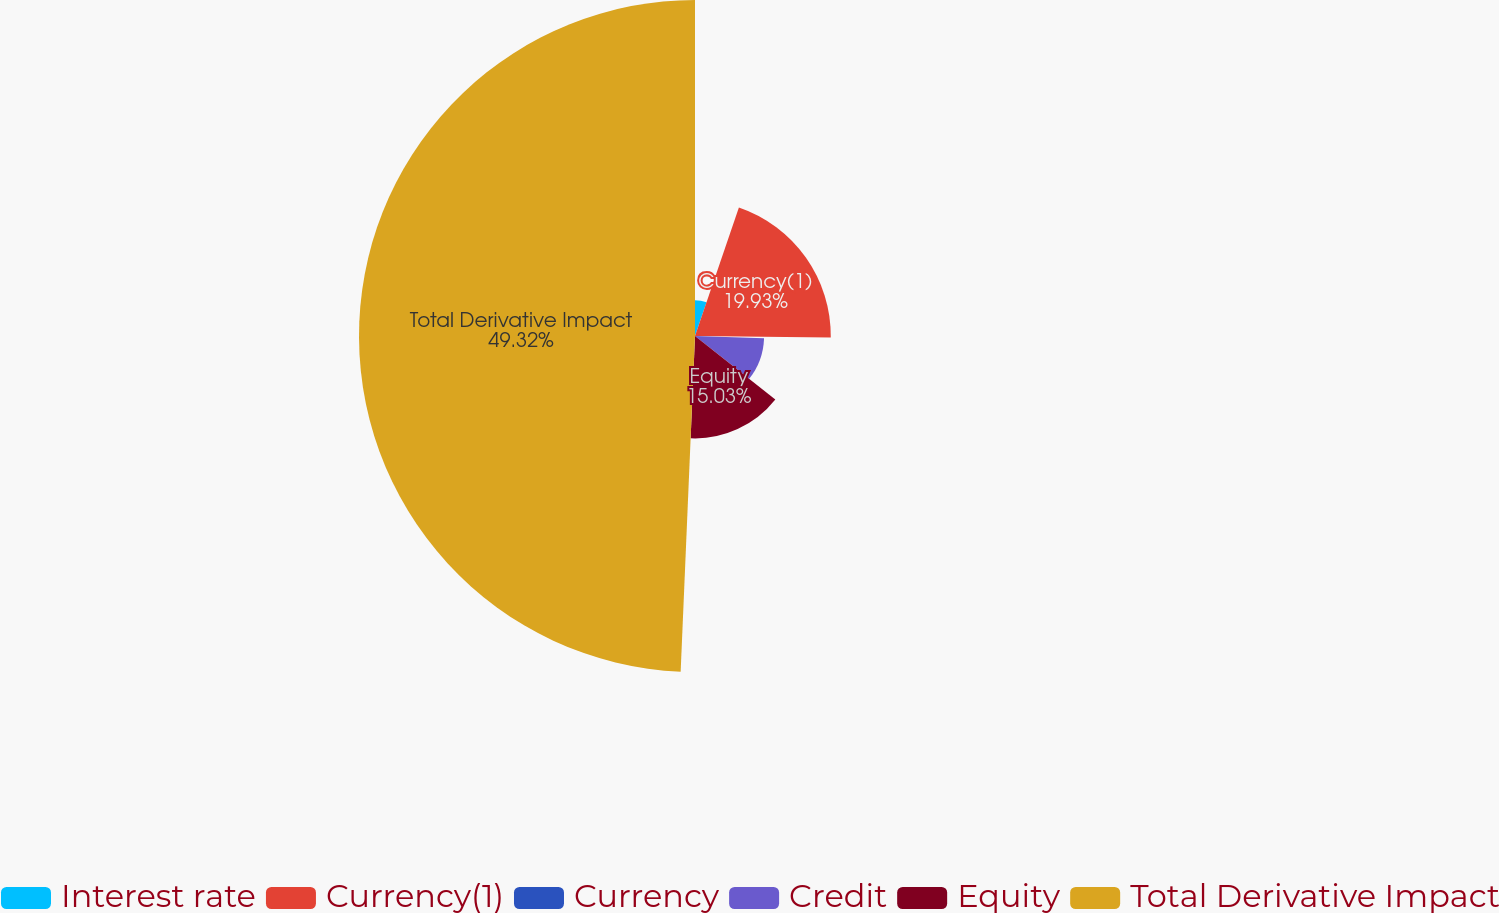<chart> <loc_0><loc_0><loc_500><loc_500><pie_chart><fcel>Interest rate<fcel>Currency(1)<fcel>Currency<fcel>Credit<fcel>Equity<fcel>Total Derivative Impact<nl><fcel>5.24%<fcel>19.93%<fcel>0.34%<fcel>10.14%<fcel>15.03%<fcel>49.32%<nl></chart> 